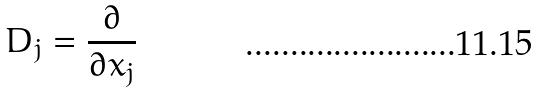<formula> <loc_0><loc_0><loc_500><loc_500>D _ { j } = \frac { \partial } { \partial x _ { j } }</formula> 